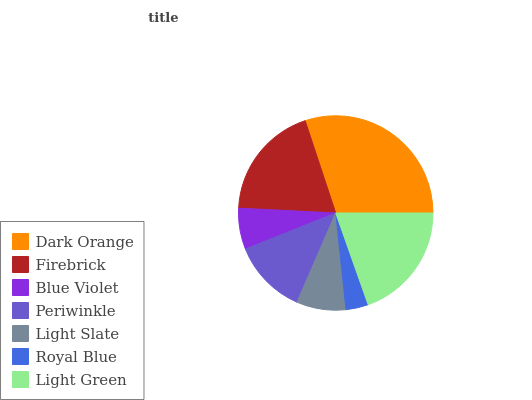Is Royal Blue the minimum?
Answer yes or no. Yes. Is Dark Orange the maximum?
Answer yes or no. Yes. Is Firebrick the minimum?
Answer yes or no. No. Is Firebrick the maximum?
Answer yes or no. No. Is Dark Orange greater than Firebrick?
Answer yes or no. Yes. Is Firebrick less than Dark Orange?
Answer yes or no. Yes. Is Firebrick greater than Dark Orange?
Answer yes or no. No. Is Dark Orange less than Firebrick?
Answer yes or no. No. Is Periwinkle the high median?
Answer yes or no. Yes. Is Periwinkle the low median?
Answer yes or no. Yes. Is Firebrick the high median?
Answer yes or no. No. Is Royal Blue the low median?
Answer yes or no. No. 